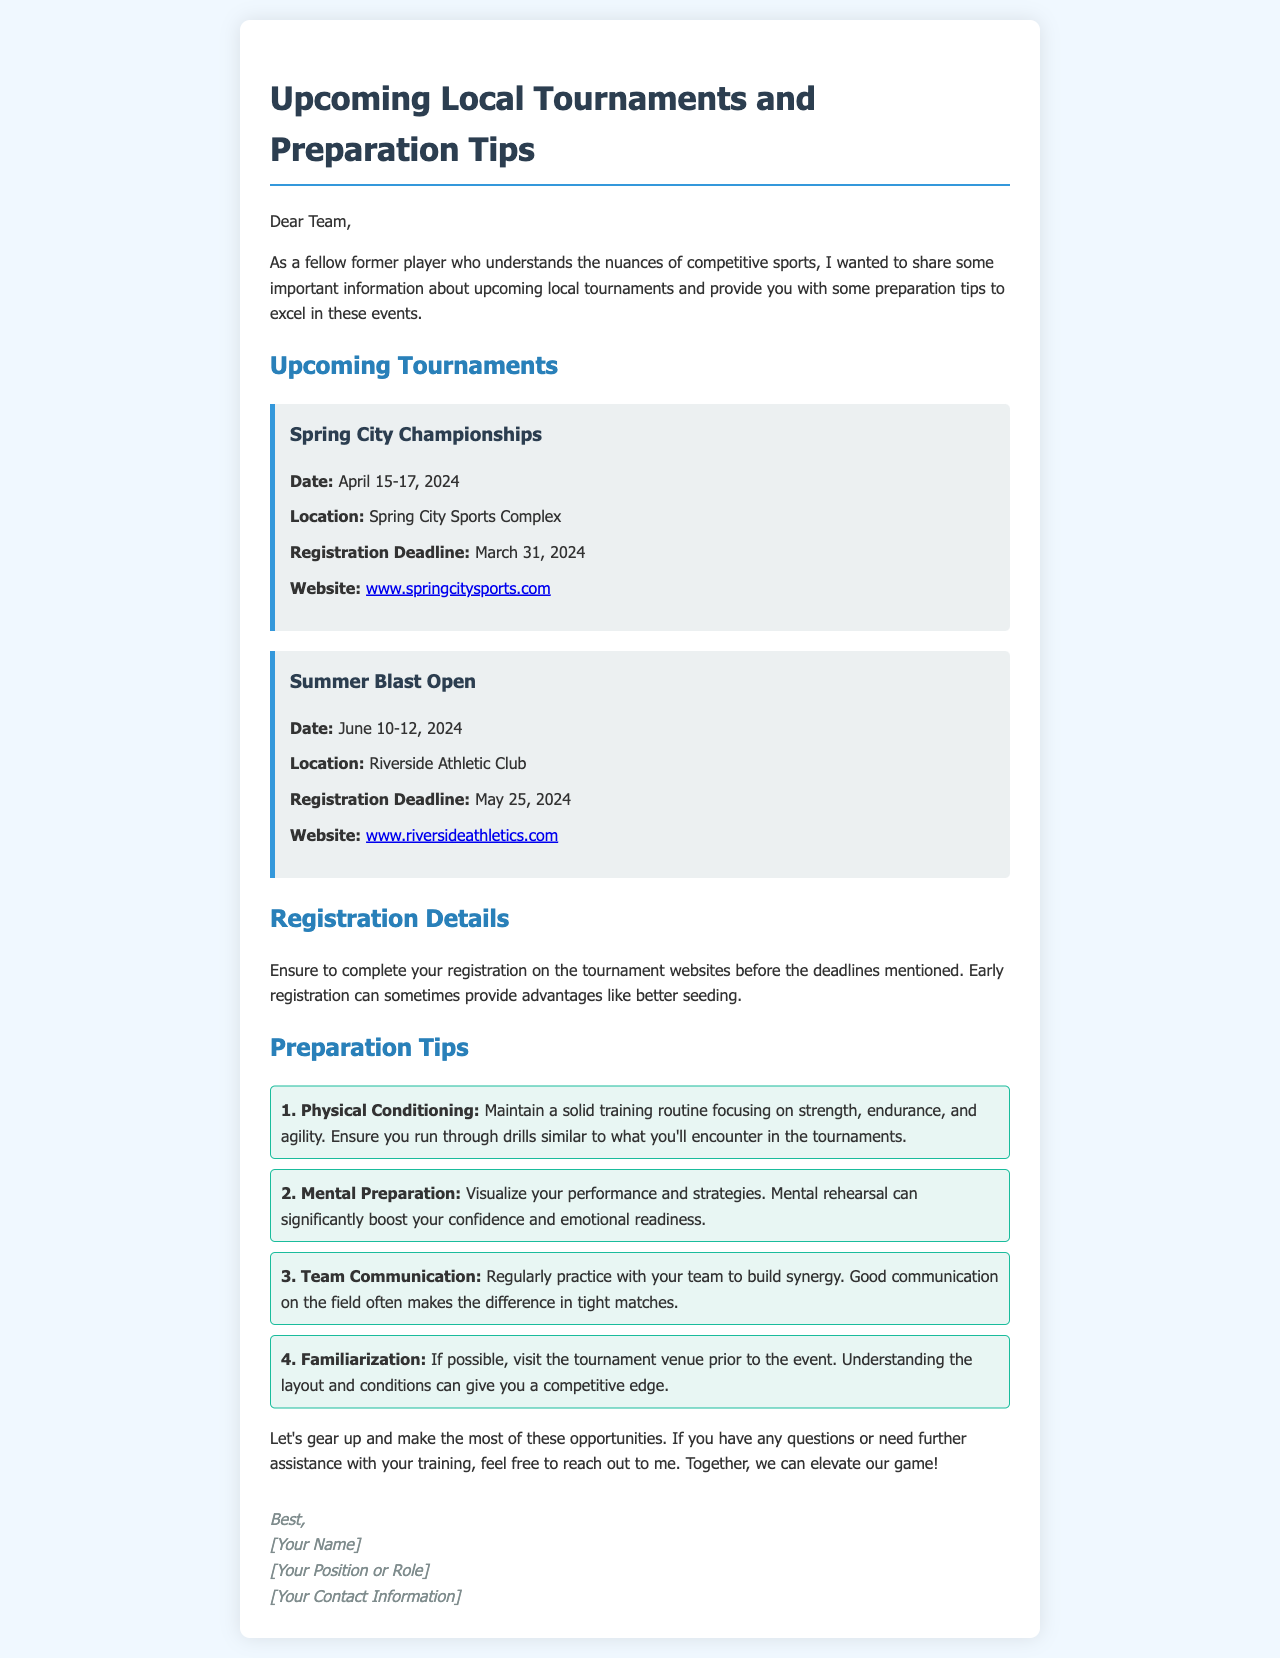What is the date of the Spring City Championships? The document states that the Spring City Championships will take place on April 15-17, 2024.
Answer: April 15-17, 2024 Where is the Summer Blast Open being held? The document indicates that the Summer Blast Open will be located at Riverside Athletic Club.
Answer: Riverside Athletic Club What is the registration deadline for the Spring City Championships? The document mentions that the registration deadline for the Spring City Championships is March 31, 2024.
Answer: March 31, 2024 What is one of the preparation tips mentioned in the document? The document outlines several preparation tips, one of which is to maintain a solid training routine focusing on strength, endurance, and agility.
Answer: Physical Conditioning What advantage does early registration provide? The document suggests that early registration can sometimes provide advantages like better seeding.
Answer: Better seeding How many preparation tips are provided in the email? The document lists four preparation tips for participants.
Answer: Four What is the website for the Spring City Championships? The document provides the website as www.springcitysports.com for the Spring City Championships.
Answer: www.springcitysports.com Who is the author of the email? The document does not specify the author's name but indicates a placeholder for [Your Name].
Answer: [Your Name] 